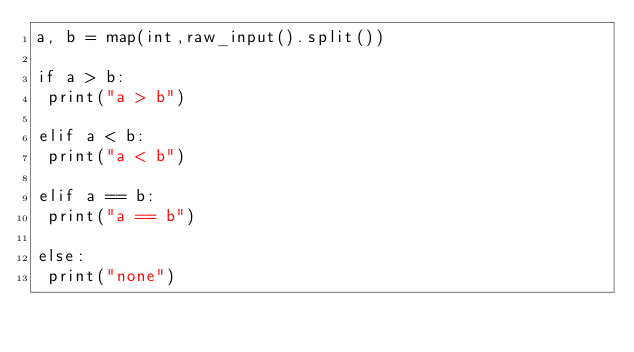Convert code to text. <code><loc_0><loc_0><loc_500><loc_500><_Python_>a, b = map(int,raw_input().split())

if a > b:
 print("a > b")

elif a < b:
 print("a < b")

elif a == b:
 print("a == b")

else:
 print("none")</code> 